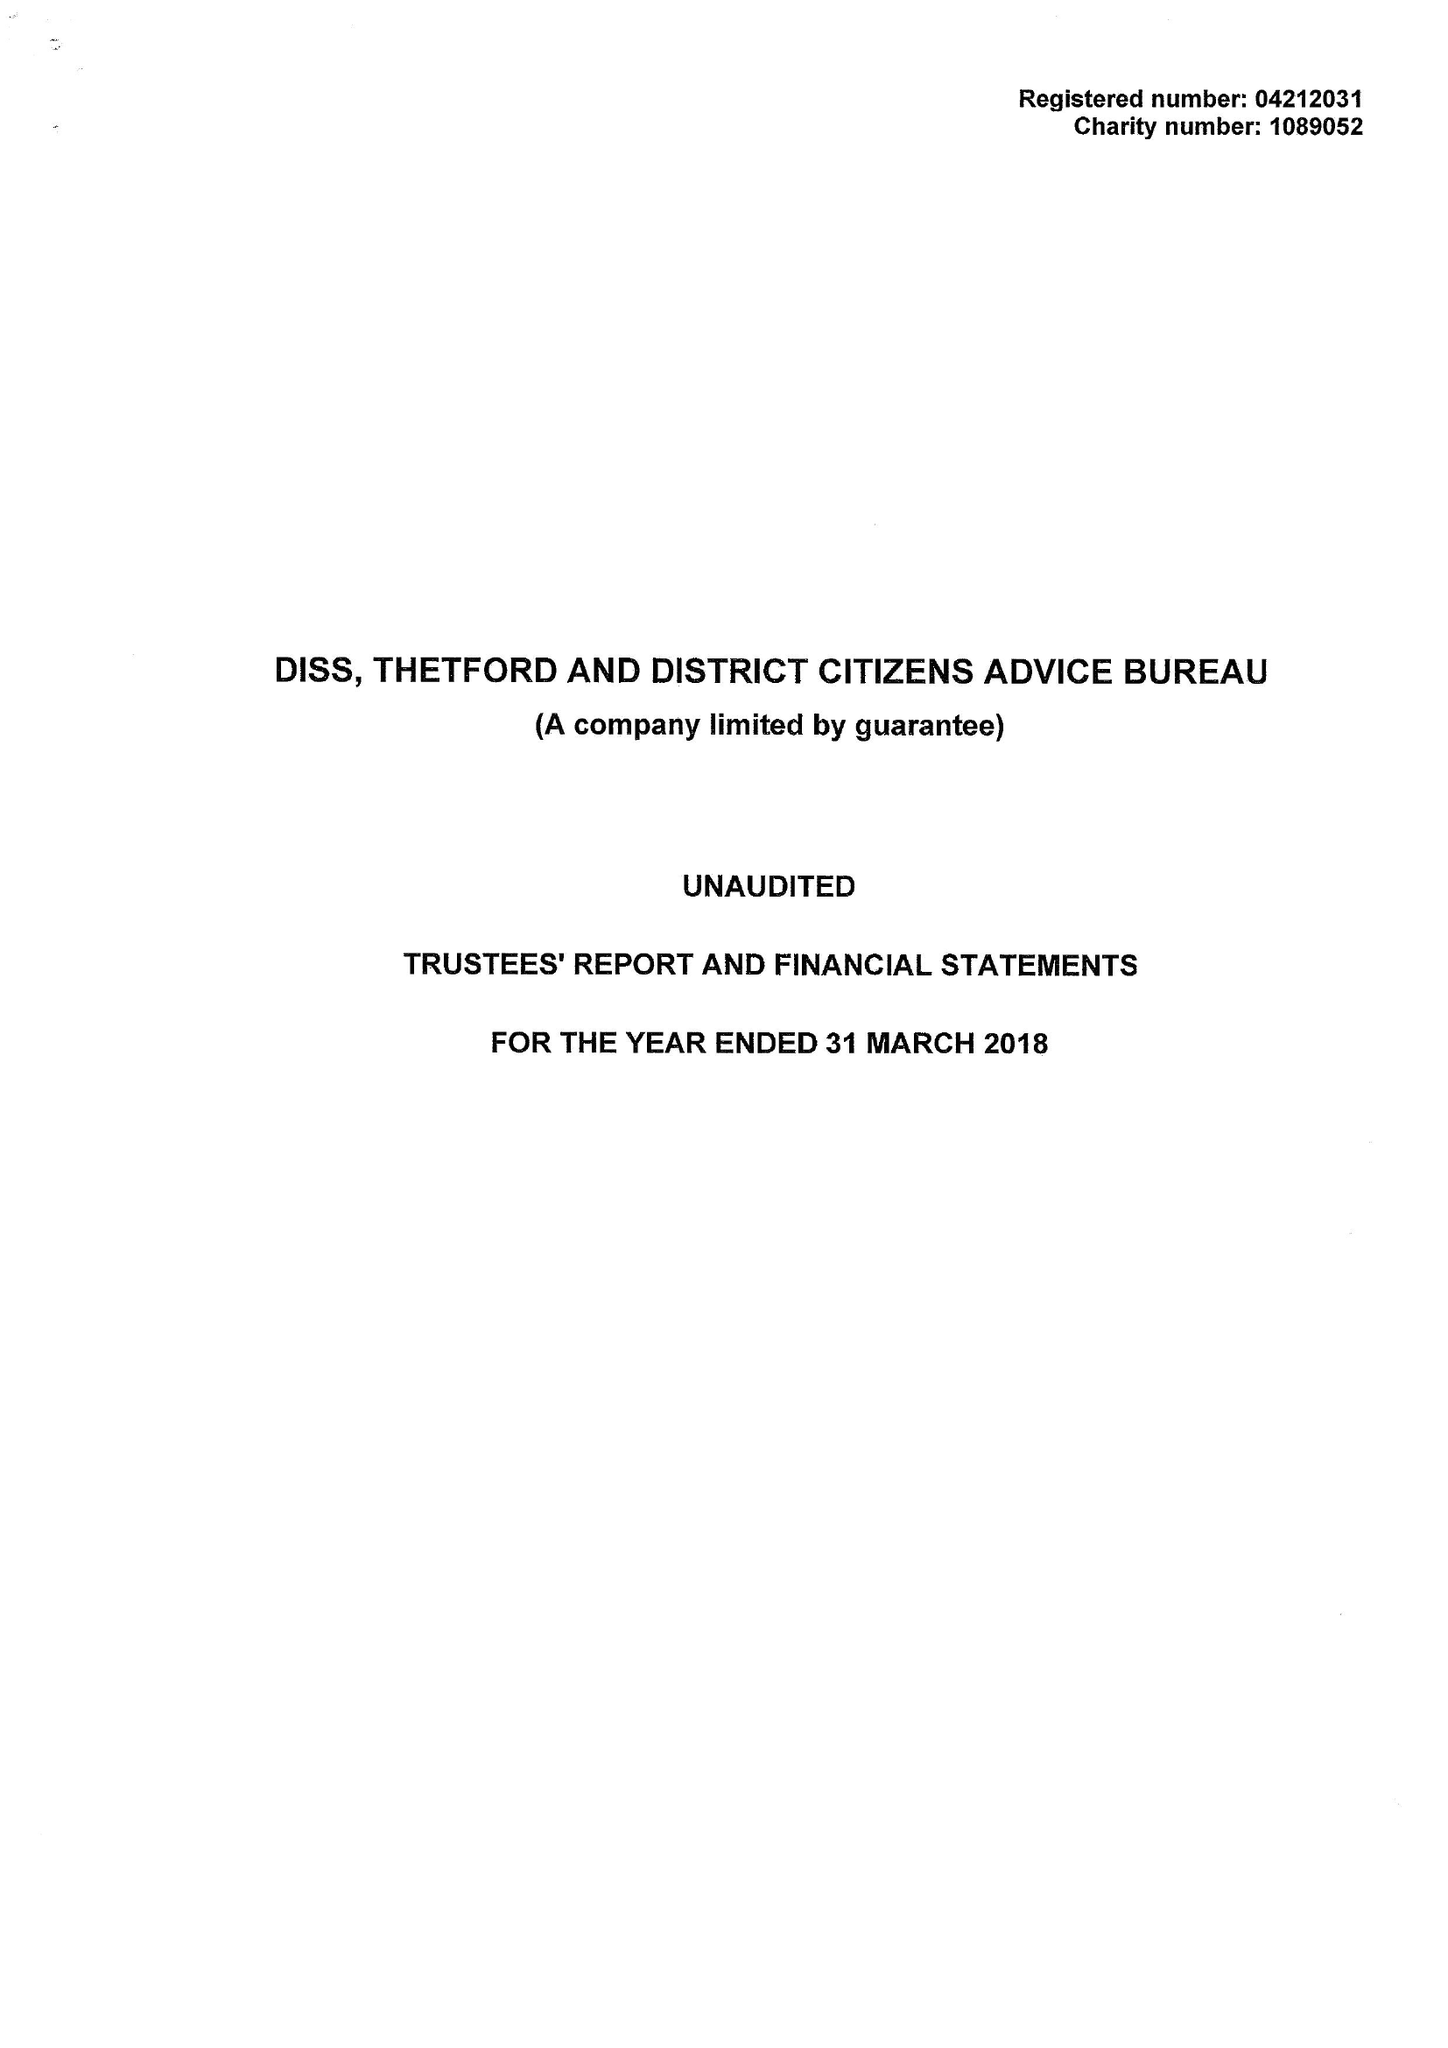What is the value for the charity_name?
Answer the question using a single word or phrase. Diss, Thetford and District Citizens Advice Bureau 